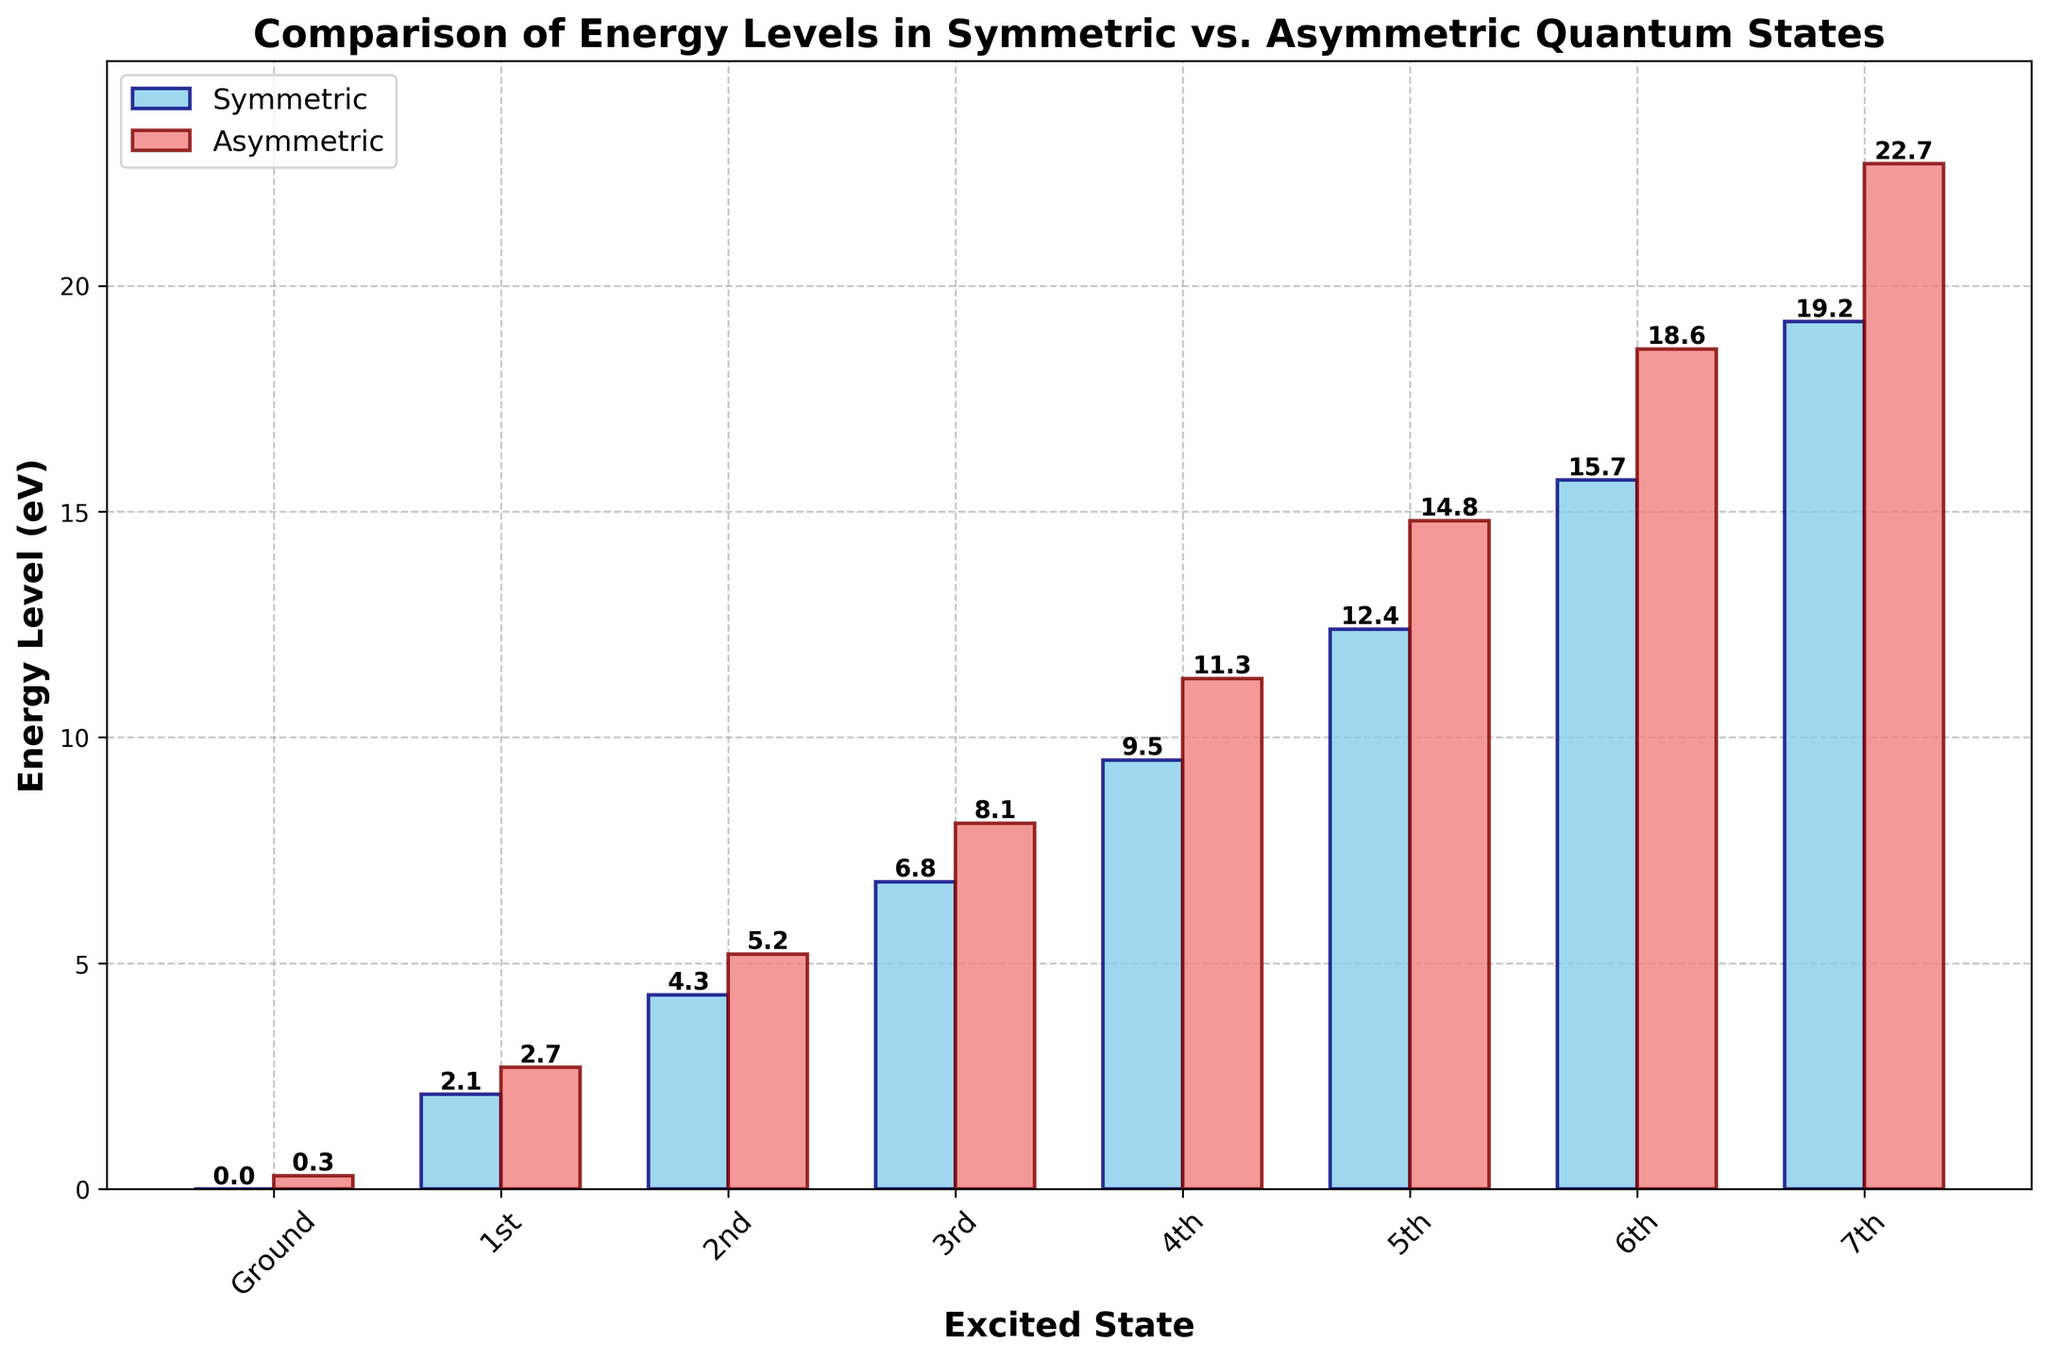What is the energy level of the Symmetric Fourth Excited State? To find the energy level of the Symmetric Fourth Excited State, locate the corresponding bar labeled '4th' for the symmetric quantum state. The bar’s height represents the energy level.
Answer: 9.5 eV Which quantum state has a higher energy level for the Second Excited State: symmetric or asymmetric? Compare the heights of the bars labeled '2nd' for both symmetric and asymmetric quantum states. The taller bar indicates the higher energy level.
Answer: Asymmetric How much higher is the energy level of the Asymmetric Ground State compared to the Symmetric Ground State? Subtract the energy level of the Symmetric Ground State from the Asymmetric Ground State. The Symmetric Ground State is at 0.0 eV and the Asymmetric Ground State is at 0.3 eV.
Answer: 0.3 eV What is the average energy level of the symmetric states up to the Seventh Excited State? Add the energy levels of the Symmetric Ground State, First, Second, Third, Fourth, Fifth, Sixth, and Seventh Excited States, then divide by 8 (number of states). The values are 0.0, 2.1, 4.3, 6.8, 9.5, 12.4, 15.7, 19.2. The sum is 70.0, so the average is 70.0 / 8.
Answer: 8.75 eV Which state shows the greatest increase in energy level from its previous state within the same symmetry category? Calculate the differences between consecutive states for both symmetric and asymmetric states, then identify the maximum difference. For the symmetric states: (2.1-0.0)=2.1, (4.3-2.1)=2.2, (6.8-4.3)=2.5, (9.5-6.8)=2.7, (12.4-9.5)=2.9, (15.7-12.4)=3.3, (19.2-15.7)=3.5. For the asymmetric states: (2.7-0.3)=2.4, (5.2-2.7)=2.5, (8.1-5.2)=2.9, (11.3-8.1)=3.2, (14.8-11.3)=3.5, (18.6-14.8)=3.8, (22.7-18.6)=4.1. The greatest increase is from Asymmetric Fifth to Sixth Excited State with 4.1 eV.
Answer: Asymmetric Fifth to Sixth How many excited states show an energy level greater than 10 eV? Count the bars whose heights are above the 10 eV mark.
Answer: 9 What is the smallest difference in energy between consecutive states in the asymmetric category? Calculate the differences between consecutive states for the asymmetric category: (2.7-0.3)=2.4, (5.2-2.7)=2.5, (8.1-5.2)=2.9, (11.3-8.1)=3.2, (14.8-11.3)=3.5, (18.6-14.8)=3.8, (22.7-18.6)=4.1. The smallest difference is between Ground and First Excited State, which is 2.4 eV.
Answer: 2.4 eV What is the energy difference between the Symmetric Third Excited State and the Asymmetric Third Excited State? Subtract the energy level of the Symmetric Third Excited State from the Asymmetric Third Excited State. The values are 6.8 for Symmetric and 8.1 for Asymmetric.
Answer: 1.3 eV Which state, symmetric or asymmetric, reaches the highest energy level in the Seventh Excited State? Compare the heights of the bars labeled '7th' for both symmetric and asymmetric quantum states. The taller bar indicates the higher energy level.
Answer: Asymmetric 